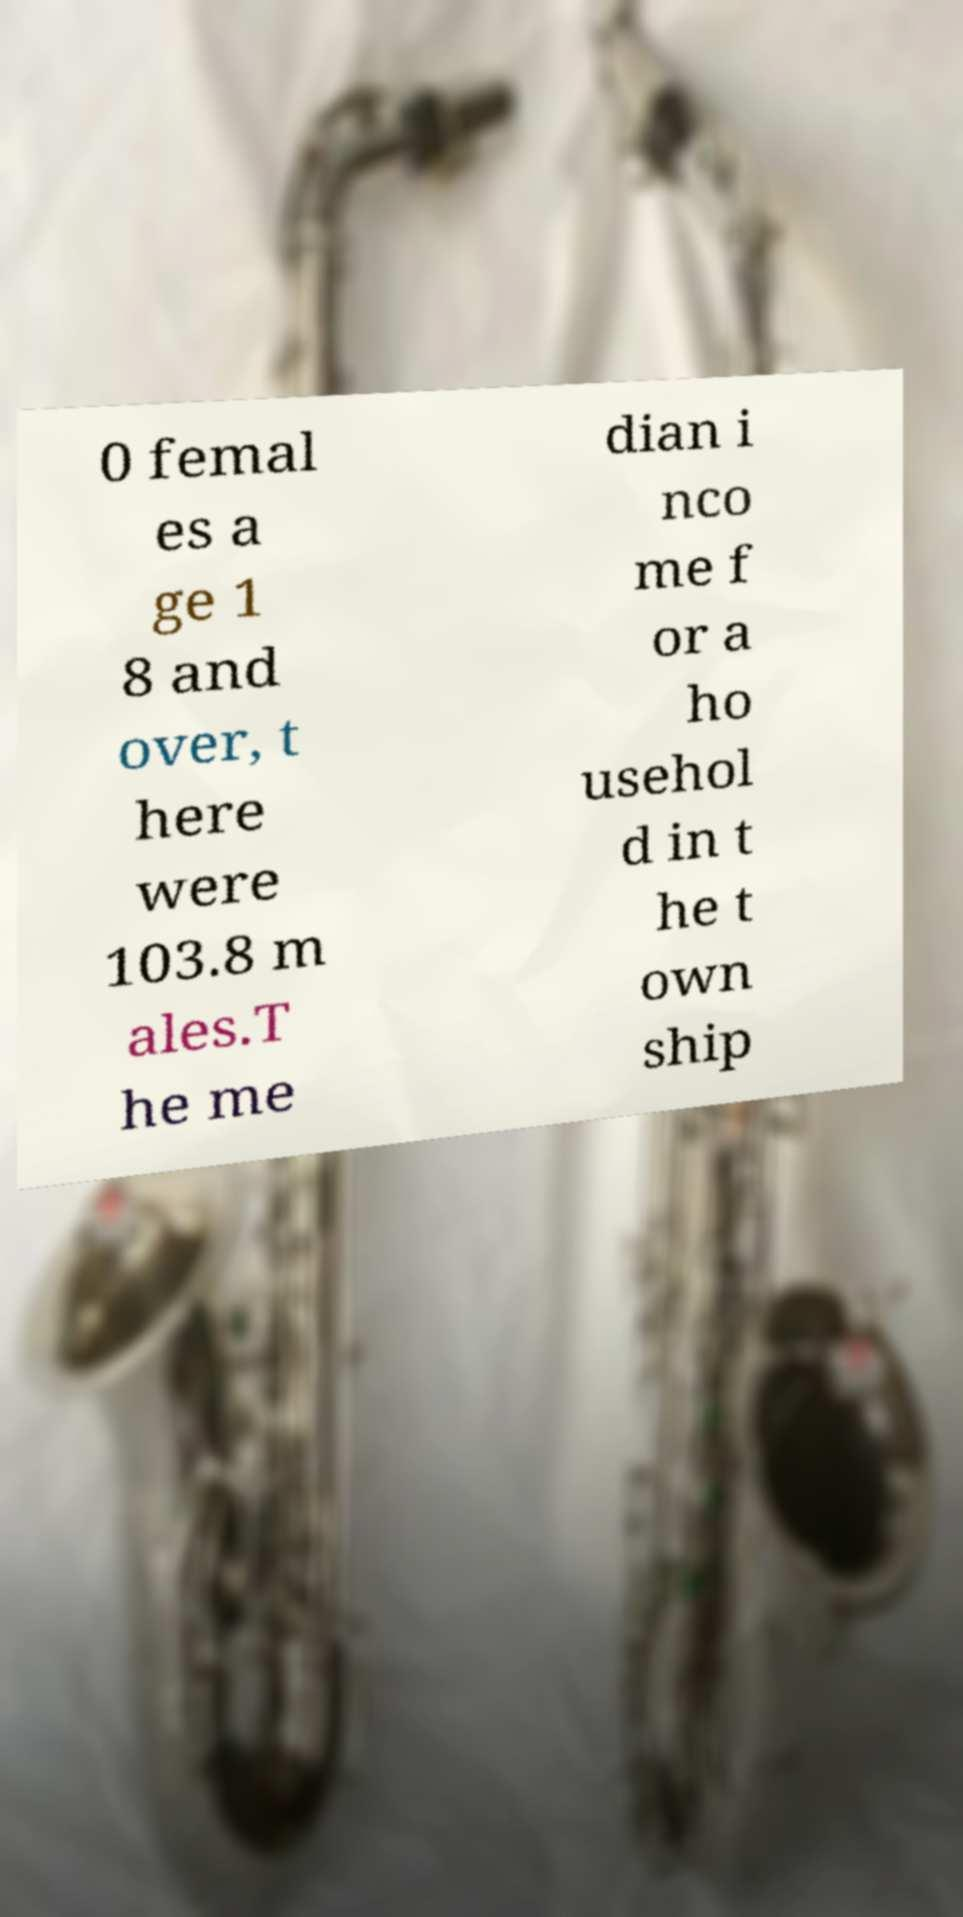What messages or text are displayed in this image? I need them in a readable, typed format. 0 femal es a ge 1 8 and over, t here were 103.8 m ales.T he me dian i nco me f or a ho usehol d in t he t own ship 